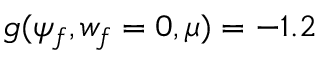<formula> <loc_0><loc_0><loc_500><loc_500>g ( \psi _ { f } , w _ { f } = 0 , \mu ) = - 1 . 2</formula> 